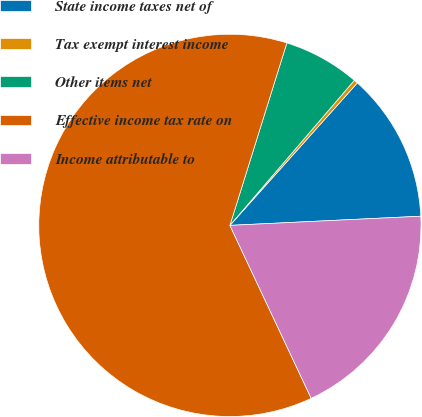Convert chart to OTSL. <chart><loc_0><loc_0><loc_500><loc_500><pie_chart><fcel>State income taxes net of<fcel>Tax exempt interest income<fcel>Other items net<fcel>Effective income tax rate on<fcel>Income attributable to<nl><fcel>12.62%<fcel>0.33%<fcel>6.47%<fcel>61.81%<fcel>18.77%<nl></chart> 